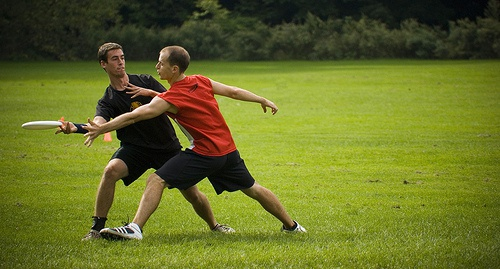Describe the objects in this image and their specific colors. I can see people in black, brown, maroon, and tan tones, people in black, olive, maroon, and gray tones, and frisbee in black, olive, and white tones in this image. 